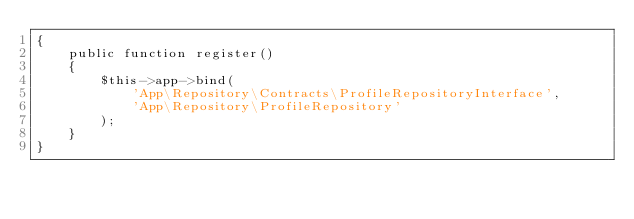<code> <loc_0><loc_0><loc_500><loc_500><_PHP_>{
    public function register()
    {
        $this->app->bind(
            'App\Repository\Contracts\ProfileRepositoryInterface',
            'App\Repository\ProfileRepository'
        );
    }
}
</code> 